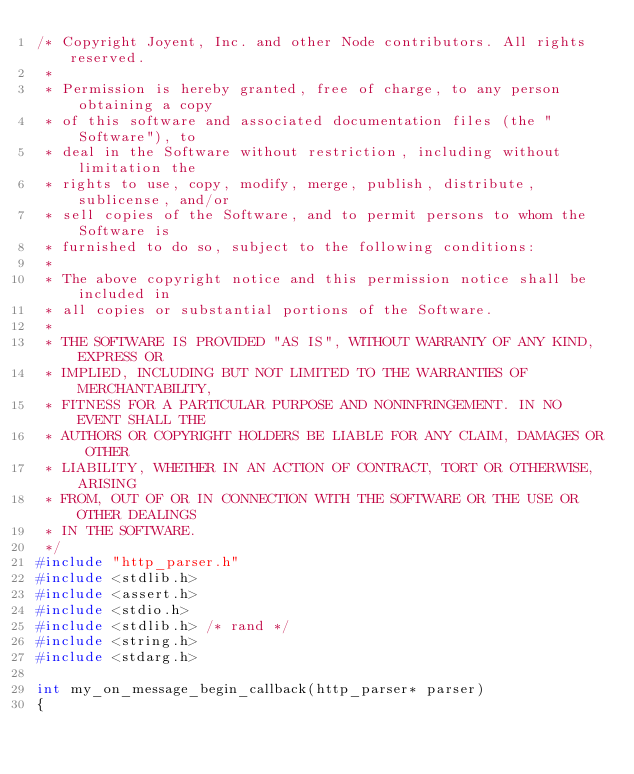Convert code to text. <code><loc_0><loc_0><loc_500><loc_500><_C_>/* Copyright Joyent, Inc. and other Node contributors. All rights reserved.
 *
 * Permission is hereby granted, free of charge, to any person obtaining a copy
 * of this software and associated documentation files (the "Software"), to
 * deal in the Software without restriction, including without limitation the
 * rights to use, copy, modify, merge, publish, distribute, sublicense, and/or
 * sell copies of the Software, and to permit persons to whom the Software is
 * furnished to do so, subject to the following conditions:
 *
 * The above copyright notice and this permission notice shall be included in
 * all copies or substantial portions of the Software.
 *
 * THE SOFTWARE IS PROVIDED "AS IS", WITHOUT WARRANTY OF ANY KIND, EXPRESS OR
 * IMPLIED, INCLUDING BUT NOT LIMITED TO THE WARRANTIES OF MERCHANTABILITY,
 * FITNESS FOR A PARTICULAR PURPOSE AND NONINFRINGEMENT. IN NO EVENT SHALL THE
 * AUTHORS OR COPYRIGHT HOLDERS BE LIABLE FOR ANY CLAIM, DAMAGES OR OTHER
 * LIABILITY, WHETHER IN AN ACTION OF CONTRACT, TORT OR OTHERWISE, ARISING
 * FROM, OUT OF OR IN CONNECTION WITH THE SOFTWARE OR THE USE OR OTHER DEALINGS
 * IN THE SOFTWARE.
 */
#include "http_parser.h"
#include <stdlib.h>
#include <assert.h>
#include <stdio.h>
#include <stdlib.h> /* rand */
#include <string.h>
#include <stdarg.h>

int my_on_message_begin_callback(http_parser* parser)
{</code> 